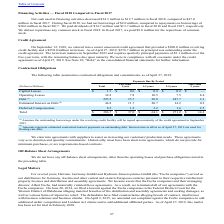According to Methode Electronics's financial document, Why does the company enter into agreements with suppliers? to assist us in meeting our customers' production needs.. The document states: "We enter into agreements with suppliers to assist us in meeting our customers' production needs. These agreements..." Also, What was the capital leases due in 1 year and 1-3 years respectively? The document shows two values: $0.6 and $0.9 (in millions). From the document: "Capital Leases $ 1.7 $ 0.6 $ 0.9 $ 0.2 $ — Capital Leases $ 1.7 $ 0.6 $ 0.9 $ 0.2 $ —..." Also, What was the total operating leases? According to the financial document, 34.2 (in millions). The relevant text states: "Operating Leases 34.2 7.8 10.5 7.5 8.4..." Also, can you calculate: What was the difference in the capital leases due from less than 1 year to those due in 1-3 years? Based on the calculation: 0.9 - 0.6, the result is 0.3 (in millions). This is based on the information: "Capital Leases $ 1.7 $ 0.6 $ 0.9 $ 0.2 $ — Capital Leases $ 1.7 $ 0.6 $ 0.9 $ 0.2 $ —..." The key data points involved are: 0.6, 0.9. Additionally, In which period was operating leases due less than 10 million? The document contains multiple relevant values: Less than 1 year, 3-5 years, More than 5 years. Locate and analyze operating leases in row 5. From the document: "1 year 1-3 years 3-5 years..." Also, can you calculate: What percentage of the total was made of debt? Based on the calculation: 295.5 / 386.7, the result is 76.42 (percentage). This is based on the information: "Debt (1) 295.5 15.7 28.8 247.7 3.3 Total $ 386.7 $ 37.0 $ 64.1 $ 271.2 $ 14.4..." The key data points involved are: 295.5, 386.7. 